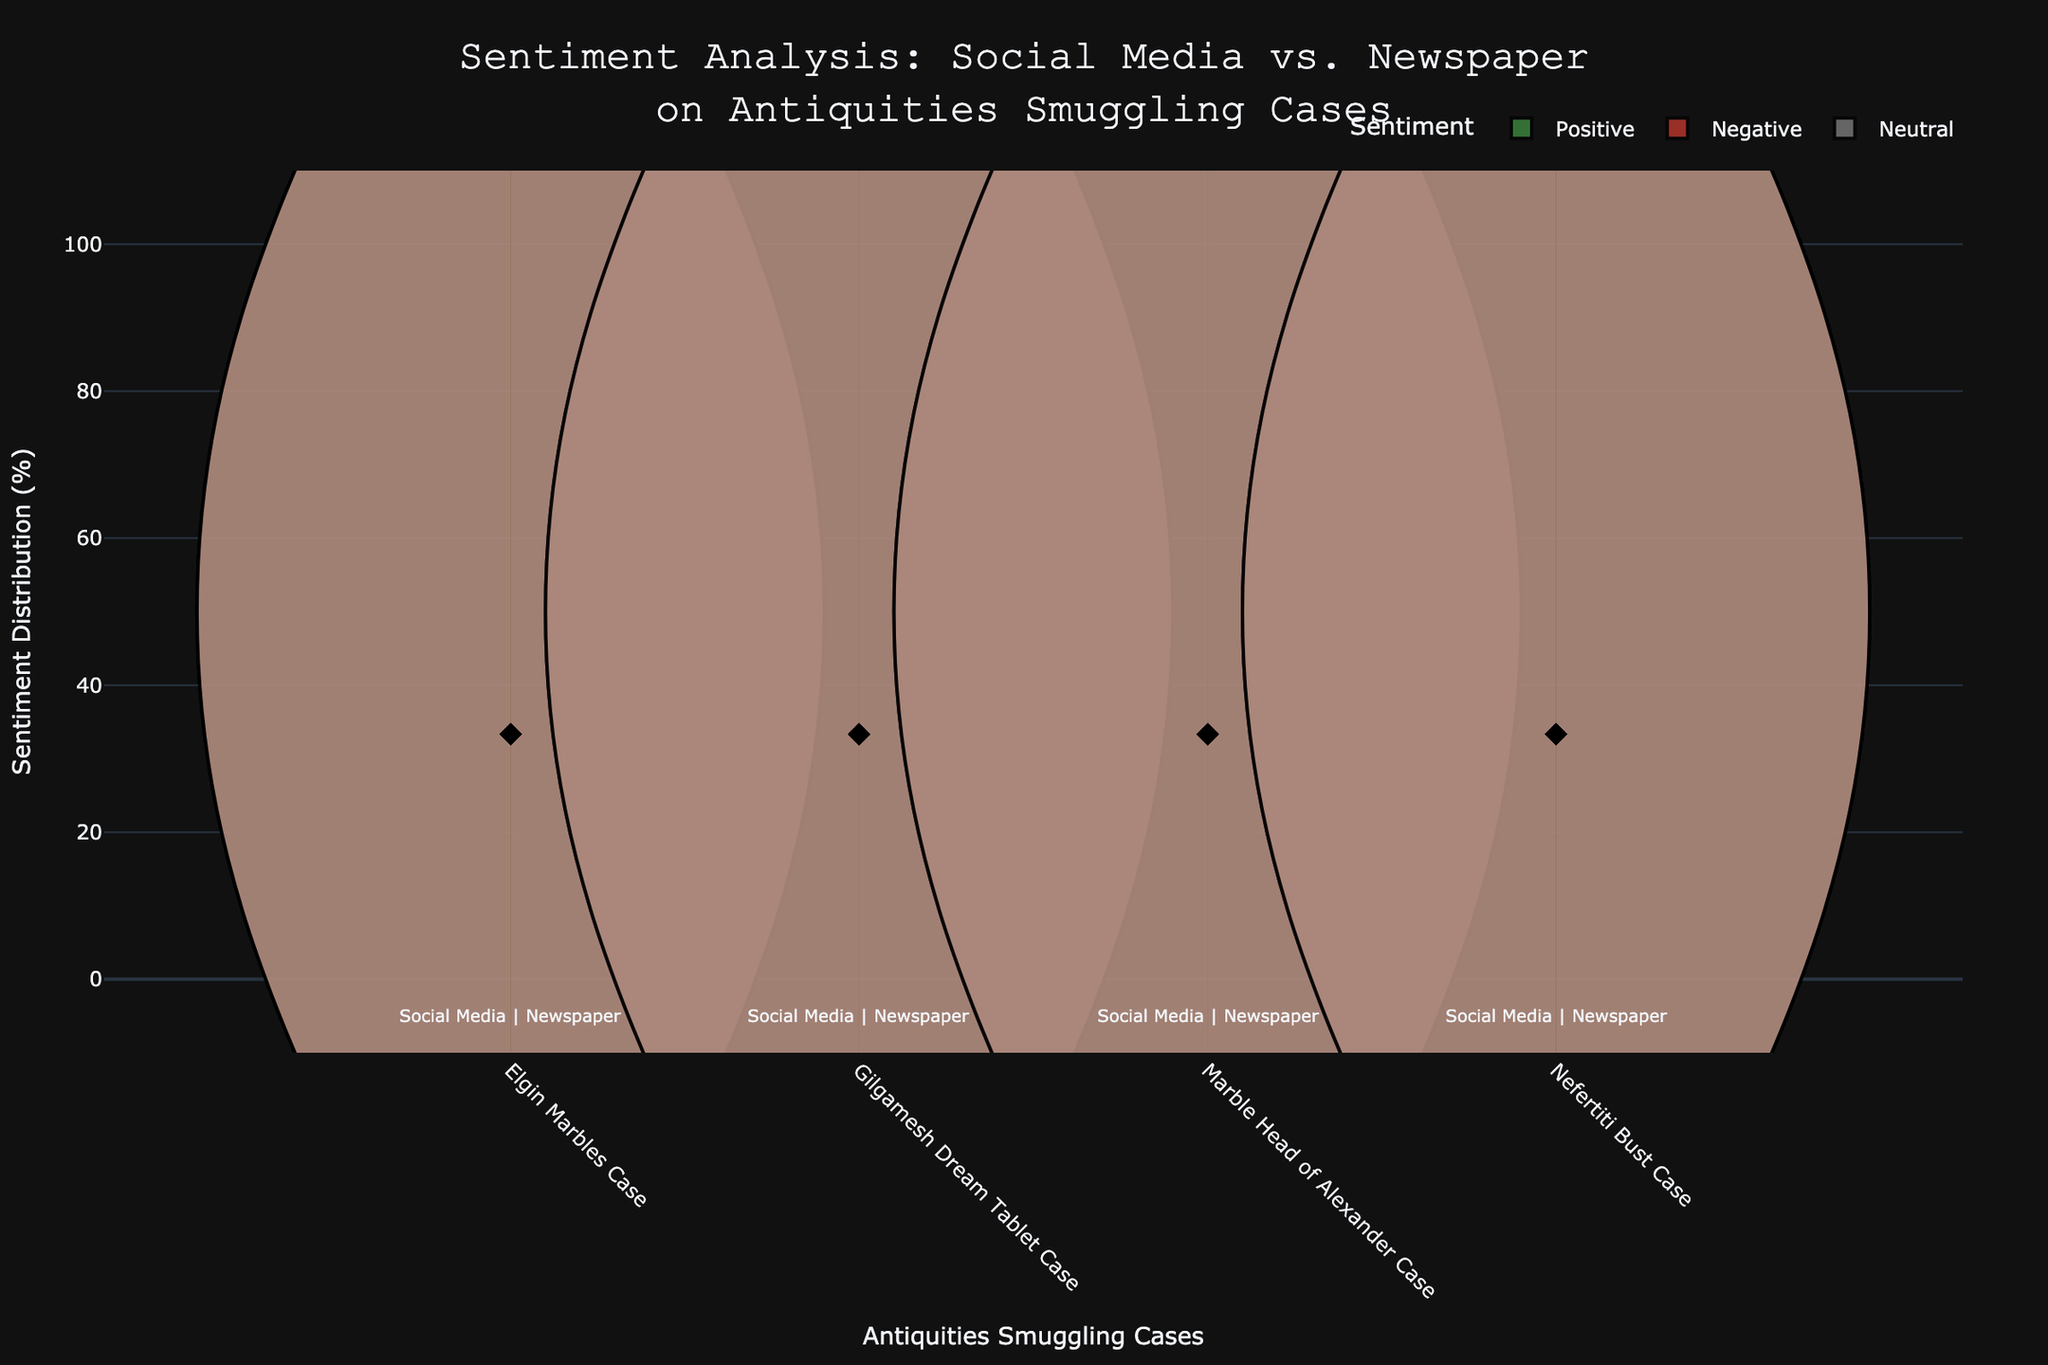What is the title of the figure? The title of the figure is prominently displayed at the top and provides information on what the figure is about. It reads, "Sentiment Analysis: Social Media vs. Newspaper on Antiquities Smuggling Cases."
Answer: Sentiment Analysis: Social Media vs. Newspaper on Antiquities Smuggling Cases Which sentiment has the highest percentage for the Elgin Marbles Case in Social Media? To find this, look at the violin plot corresponding to the "Elgin Marbles Case" for Social Media and note the percentage markers for Positive, Negative, and Neutral sentiments. The highest point on the corresponding side indicates the highest sentiment percentage.
Answer: Positive How does the sentiment percentage for the Gilgamesh Dream Tablet Case in Newspaper compare between Positive and Negative sentiments? Analyze the violin plot for the Gilgamesh Dream Tablet Case under Newspaper. Compare the heights of the Positive and Negative percentages; it will help you see which sentiment is more prominent.
Answer: Positive is higher Which entity shows a larger difference in Negative sentiment between Social Media and Newspaper? Identify the entities and assess the violin plots for Negative sentiments in both Social Media and Newspaper. Calculate the difference in percentages for each entity to determine which has the largest gap.
Answer: Marble Head of Alexander Case What is the average Positive sentiment percentage across all entities for Social Media? To calculate this, sum up the Positive sentiment percentages for the Elgin Marbles, Gilgamesh Dream Tablet, Marble Head of Alexander, and Nefertiti Bust cases in Social Media. Then divide by the number of entities (4).
Answer: Average of the individual Positive percentages Is the distribution of Neutral sentiment more uniform across Social Media or Newspapers? Compare the violin plots for Neutral sentiment across all entities in both Social Media and Newspaper. Assess the consistency and spread of the percentages to determine uniformity.
Answer: Social Media Which case has the lowest Negative sentiment percentage in Social Media? Look at the violin plots for Negative sentiment under Social Media for each case. Identify the case with the lowest peak on the Negative sentiment side.
Answer: Nefertiti Bust Case Do any of the cases have equal Positive sentiment percentages in Social Media and Newspaper? Compare the Positive sentiment percentage of each case in Social Media with its counterpart in Newspaper. Look for exact overlaps in percentage values.
Answer: No 